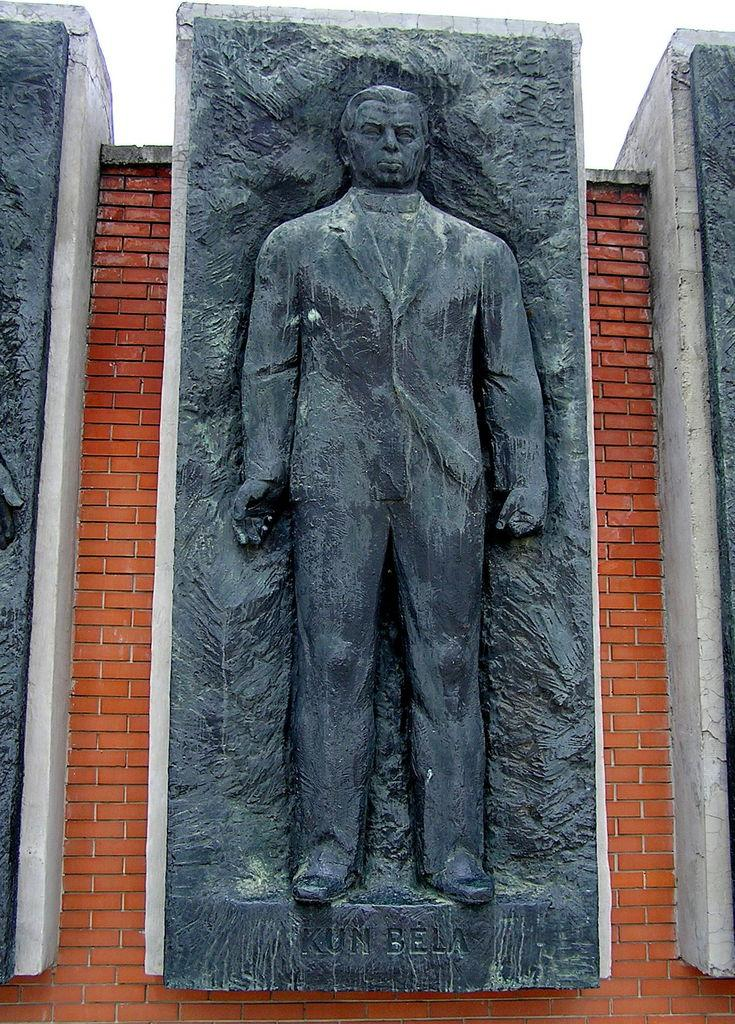What is the main subject of the image? The main subject of the image is a person sculpture. Where is the person sculpture located in the image? The person sculpture is on the wall. What type of flag is being waved during the protest in the image? There is no flag or protest present in the image; it only features a person sculpture on the wall. 